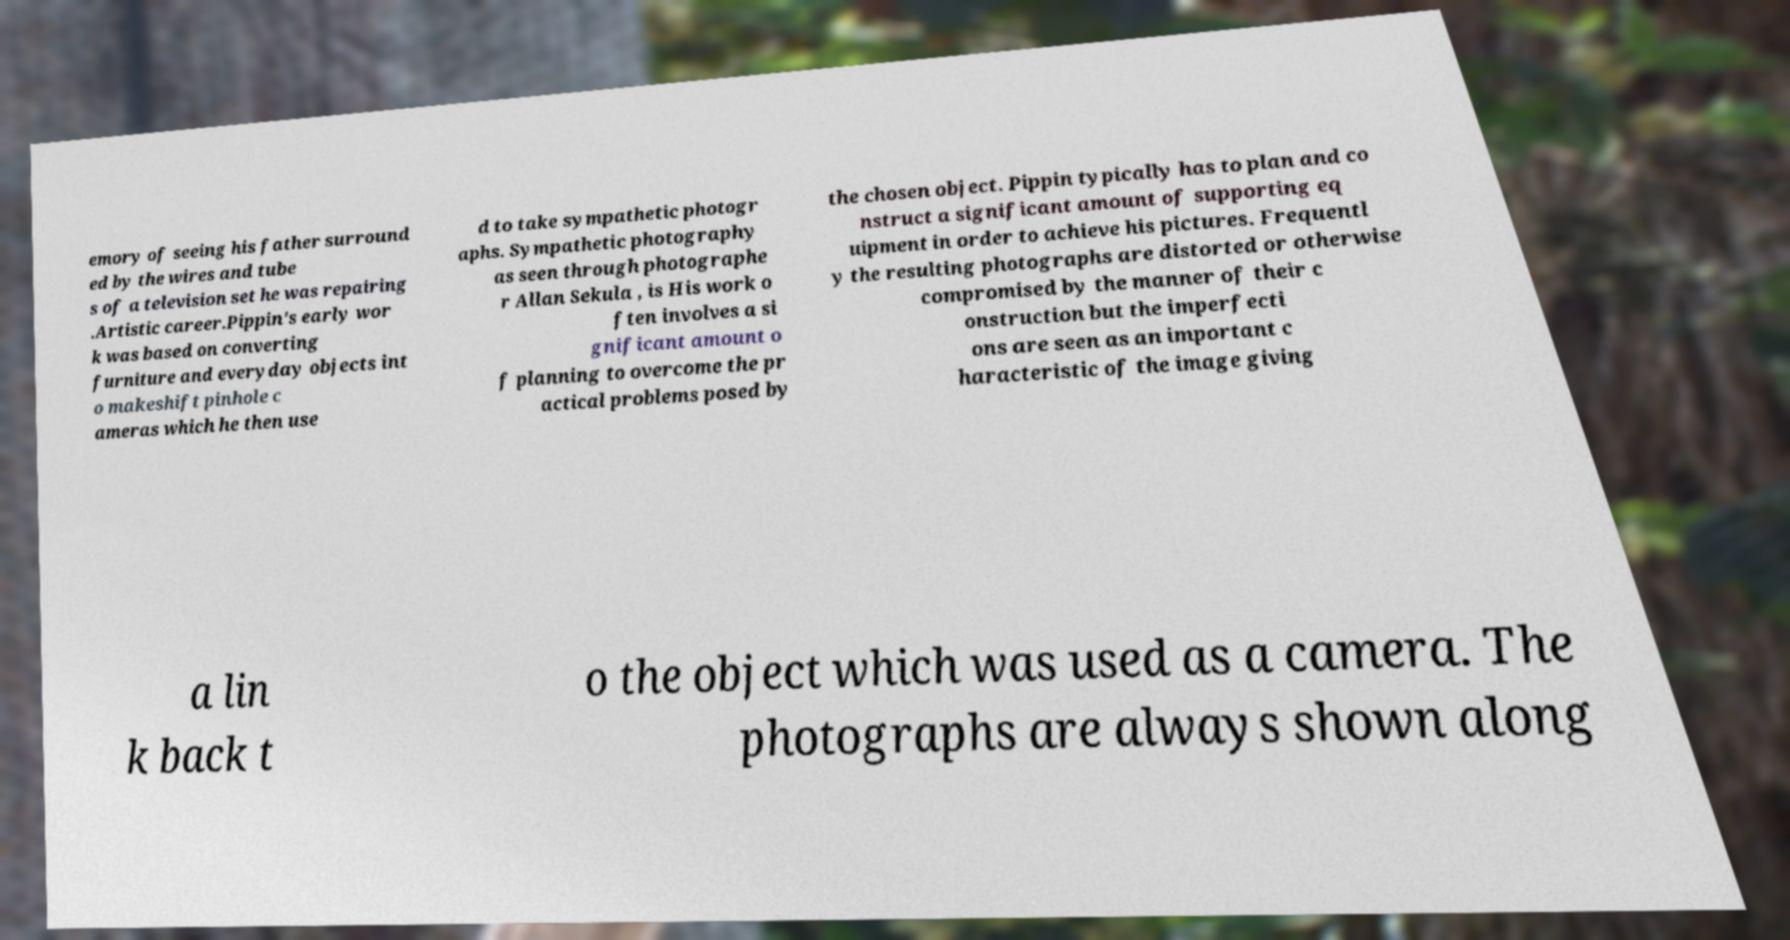Could you assist in decoding the text presented in this image and type it out clearly? emory of seeing his father surround ed by the wires and tube s of a television set he was repairing .Artistic career.Pippin's early wor k was based on converting furniture and everyday objects int o makeshift pinhole c ameras which he then use d to take sympathetic photogr aphs. Sympathetic photography as seen through photographe r Allan Sekula , is His work o ften involves a si gnificant amount o f planning to overcome the pr actical problems posed by the chosen object. Pippin typically has to plan and co nstruct a significant amount of supporting eq uipment in order to achieve his pictures. Frequentl y the resulting photographs are distorted or otherwise compromised by the manner of their c onstruction but the imperfecti ons are seen as an important c haracteristic of the image giving a lin k back t o the object which was used as a camera. The photographs are always shown along 